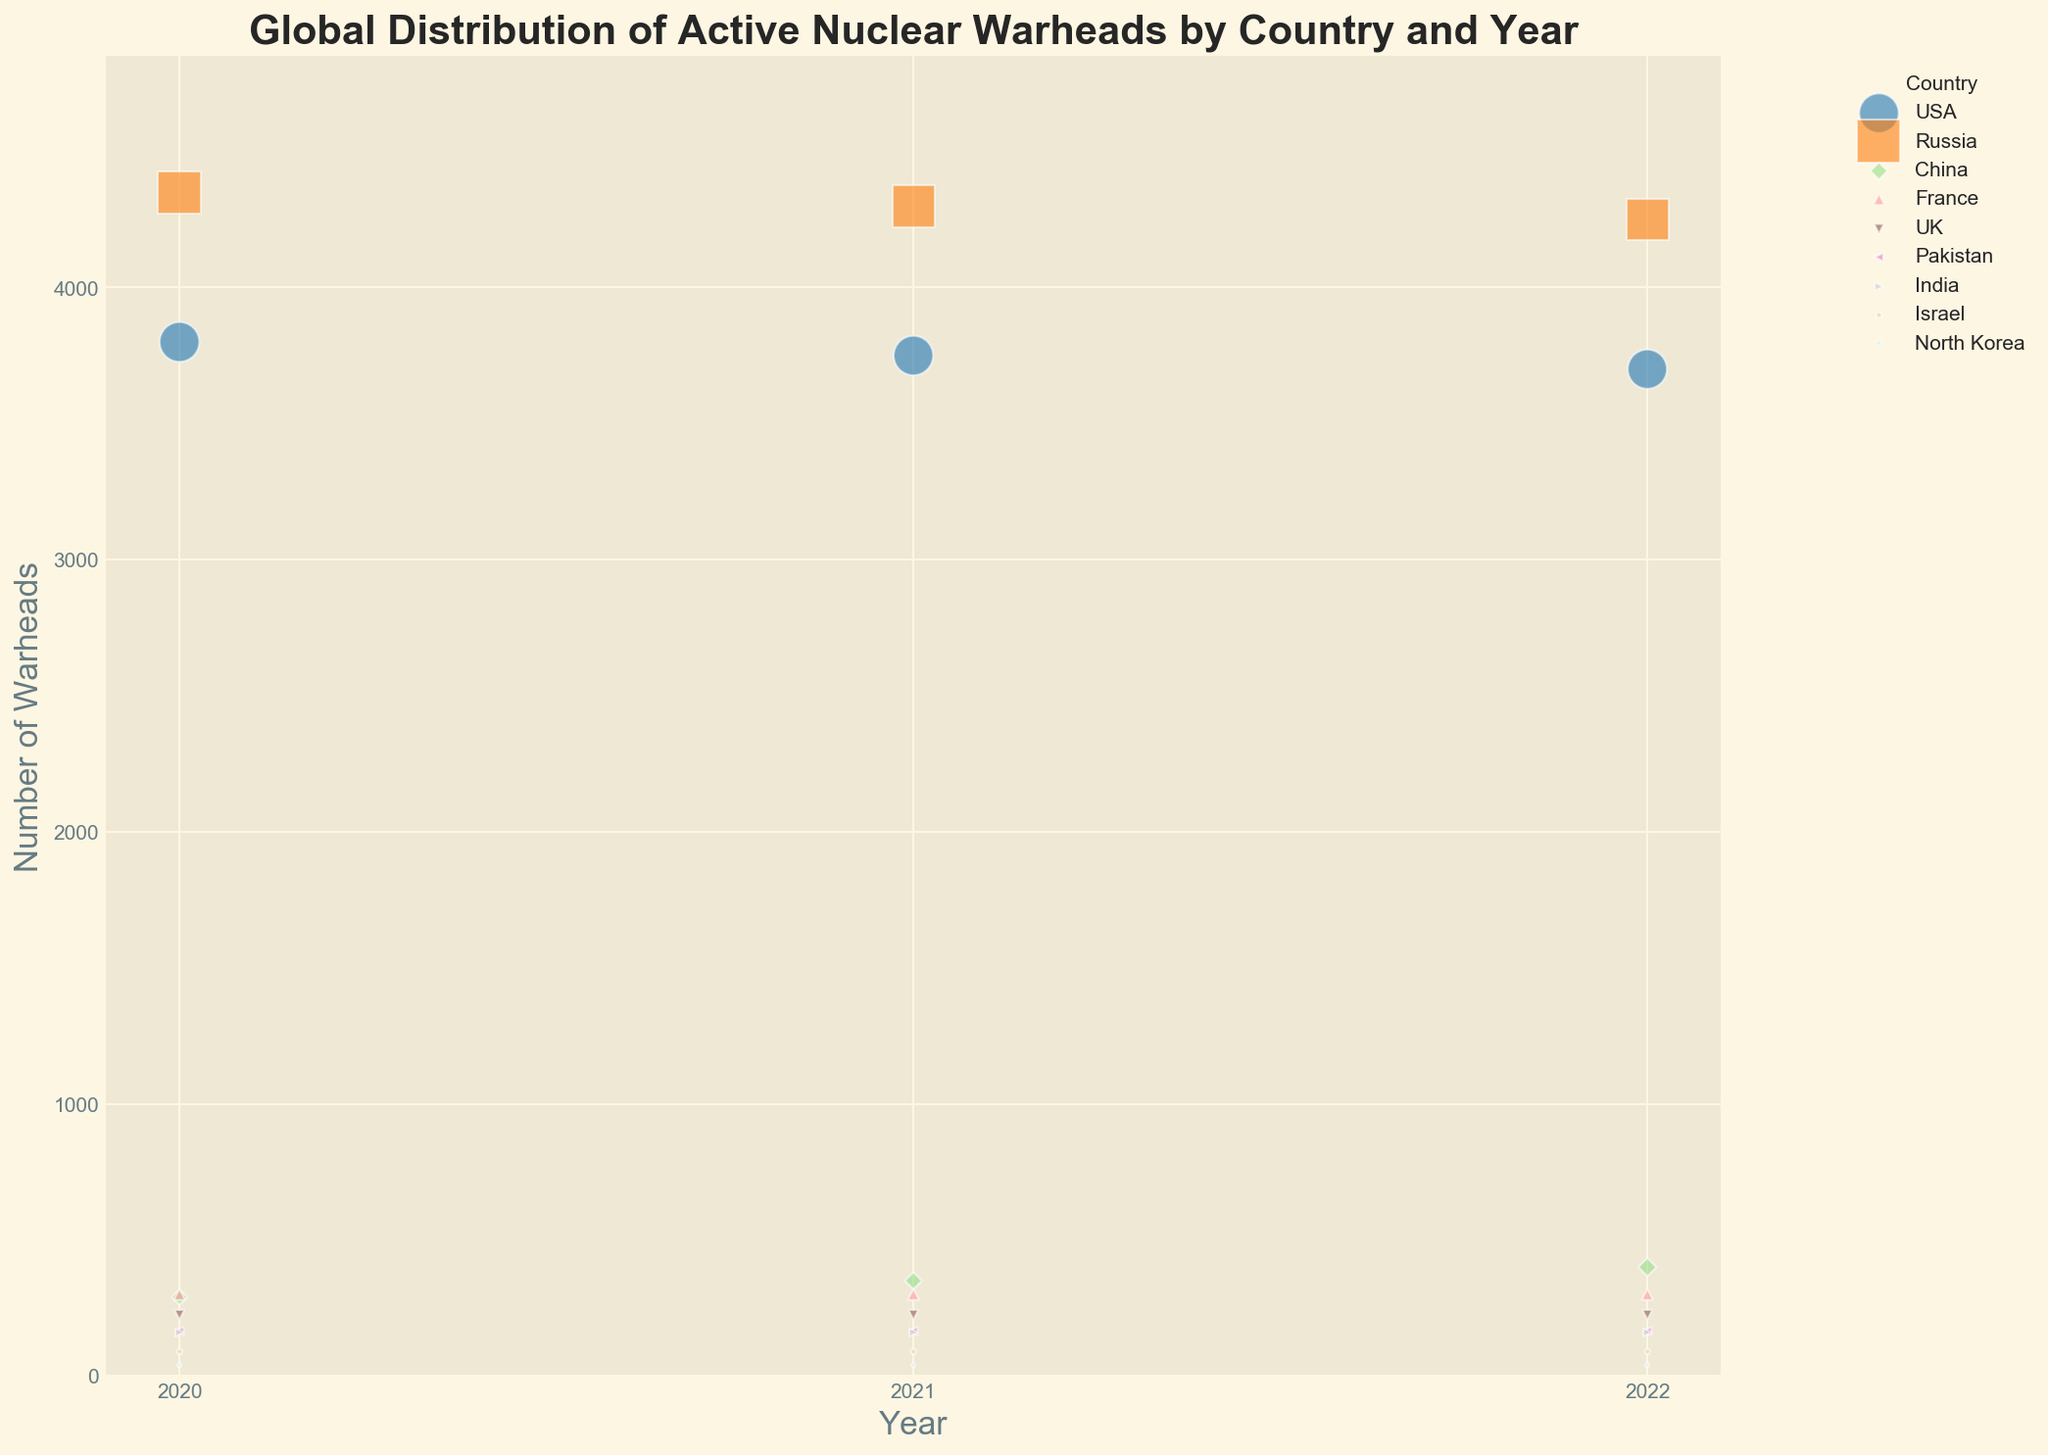Which country had the most active nuclear warheads in 2022? By examining the scatter plot for the year 2022, I identify the point with the highest y-axis value. Russia's bubble is at the highest position with 4250 warheads.
Answer: Russia What trend is observed in the number of warheads for the USA from 2020 to 2022? Analyzing the series of bubbles for the USA across the years 2020, 2021, and 2022, I see that the number of warheads decreases each year: 3800 in 2020, 3750 in 2021, and 3700 in 2022.
Answer: Decreasing Which country had an increase in warheads from 2020 to 2021 and then to 2022? By reviewing the positions and sizes of the bubbles year by year, China shows an increase in its number of warheads each year: 290 in 2020, 350 in 2021, and 400 in 2022.
Answer: China How does the number of warheads for France in 2022 compare to that in 2020? The bubbles for France in years 2020, 2021, and 2022 remain at the same y-axis level. Therefore, France maintained the same number of warheads, 300, across these years.
Answer: Equal Which two countries have the same number of warheads from 2020 to 2022? By checking the bubbles' y-axis placement for all years, I see that the bubbles for the UK and Pakistan overlap, indicating they both maintained the same count: 225 for the UK and 165 for Pakistan.
Answer: UK and Pakistan What is the percentage increase in China's warheads from 2020 to 2022? China's warhead count increased from 290 to 400. The percentage increase is calculated as ((400 - 290) / 290) * 100%. This results in approximately 37.93%.
Answer: 37.93% Which country had the smallest number of warheads in 2020? Looking at the bubbles' positions on the y-axis for 2020, North Korea's bubble is the lowest, indicating it had the smallest number of warheads, which is 40.
Answer: North Korea Compare the number of warheads in 2022 for Israel and North Korea. Which one has more and by how much? Israel has a bubble indicating 90 warheads, and North Korea has 40. The difference is 90 - 40 = 50 warheads more for Israel.
Answer: Israel, 50 more What is the median number of warheads among all countries in 2022? Listing the warhead counts for 2022: 4250, 3700, 400, 300, 225, 165, 160, 90, 40, I identify the middle value in this sorted list, which is 225 for the UK.
Answer: 225 How did the total number of warheads for the USA and Russia change from 2020 to 2022? Summing the warheads for the USA and Russia in 2020 gives 3800 + 4350 = 8150. In 2022, it is 3700 + 4250 = 7950. The total number decreased from 8150 to 7950, a decrease of 200 warheads.
Answer: Decreased by 200 